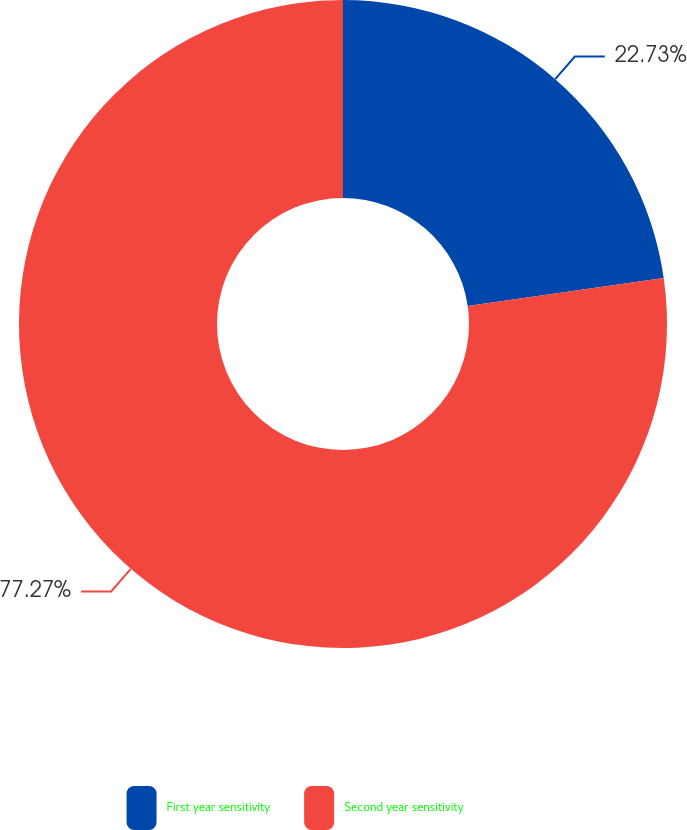<chart> <loc_0><loc_0><loc_500><loc_500><pie_chart><fcel>First year sensitivity<fcel>Second year sensitivity<nl><fcel>22.73%<fcel>77.27%<nl></chart> 